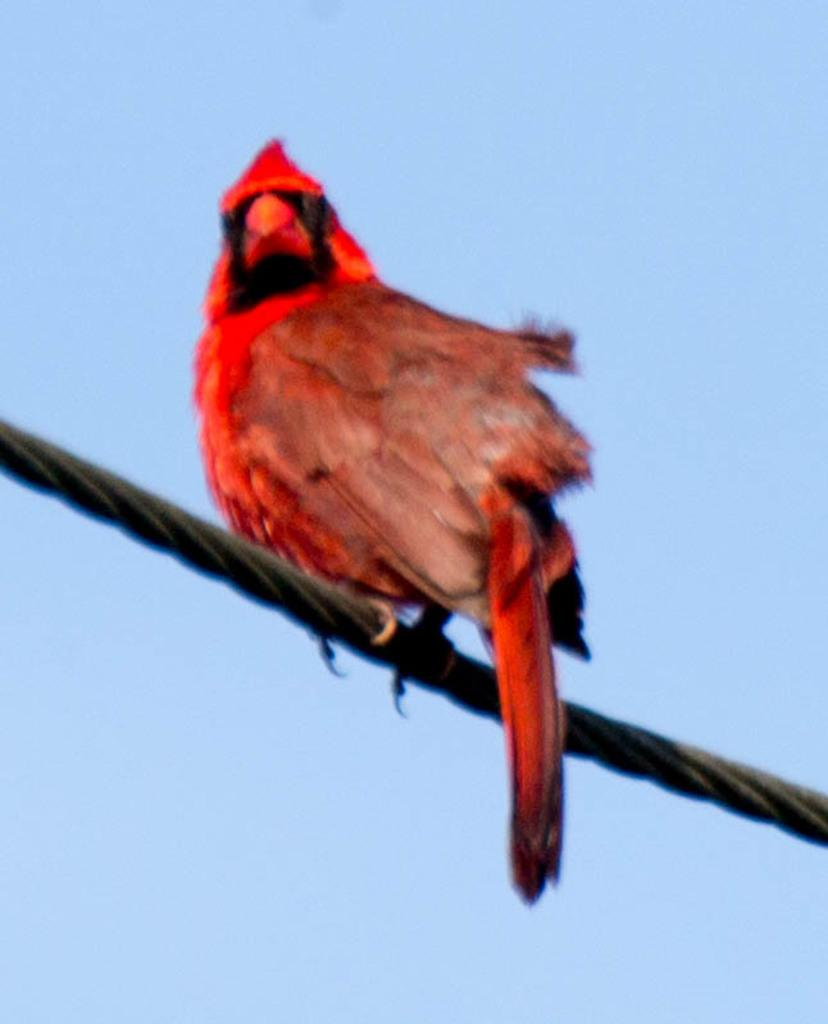What type of animal can be seen in the image? There is a bird in the image. Where is the bird located? The bird is on a cable. What caused the bird to stop flying in the image? There is no indication in the image that the bird has stopped flying or that there is a cause for it to do so. 